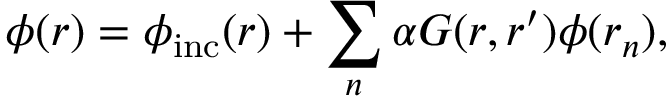<formula> <loc_0><loc_0><loc_500><loc_500>\phi ( r ) = \phi _ { i n c } ( r ) + \sum _ { n } \alpha G ( r , r ^ { \prime } ) \phi ( r _ { n } ) ,</formula> 